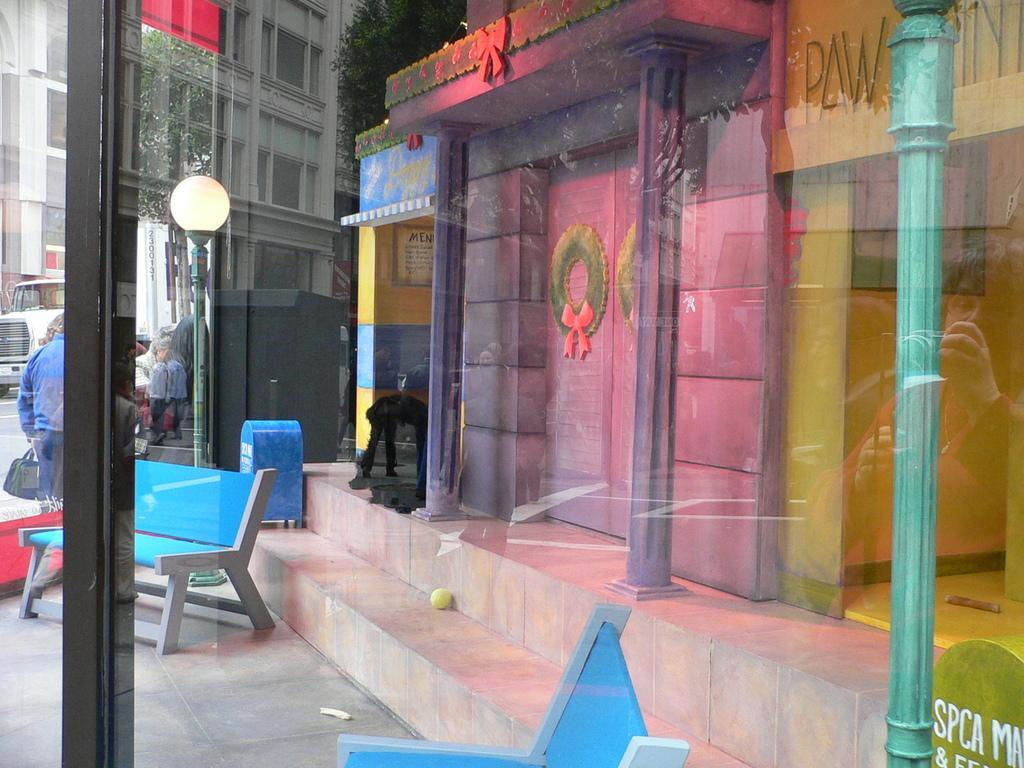Can you describe this image briefly? In this picture we can see glass, few benches and buildings, in the background we can find few people, trees, light and a truck. 